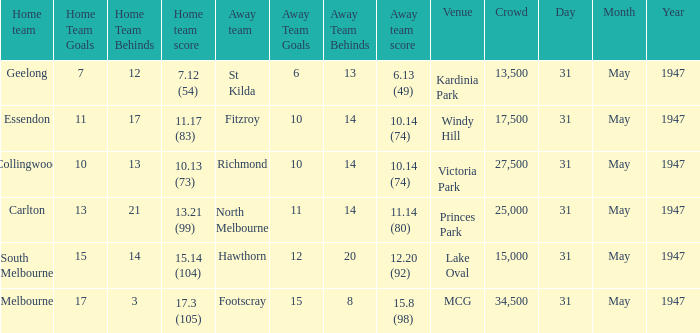Parse the full table. {'header': ['Home team', 'Home Team Goals', 'Home Team Behinds', 'Home team score', 'Away team', 'Away Team Goals', 'Away Team Behinds', 'Away team score', 'Venue', 'Crowd', 'Day', 'Month', 'Year'], 'rows': [['Geelong', '7', '12', '7.12 (54)', 'St Kilda', '6', '13', '6.13 (49)', 'Kardinia Park', '13,500', '31', 'May', '1947'], ['Essendon', '11', '17', '11.17 (83)', 'Fitzroy', '10', '14', '10.14 (74)', 'Windy Hill', '17,500', '31', 'May', '1947'], ['Collingwood', '10', '13', '10.13 (73)', 'Richmond', '10', '14', '10.14 (74)', 'Victoria Park', '27,500', '31', 'May', '1947'], ['Carlton', '13', '21', '13.21 (99)', 'North Melbourne', '11', '14', '11.14 (80)', 'Princes Park', '25,000', '31', 'May', '1947'], ['South Melbourne', '15', '14', '15.14 (104)', 'Hawthorn', '12', '20', '12.20 (92)', 'Lake Oval', '15,000', '31', 'May', '1947'], ['Melbourne', '17', '3', '17.3 (105)', 'Footscray', '15', '8', '15.8 (98)', 'MCG', '34,500', '31', 'May', '1947']]} What is the home team's score at mcg? 17.3 (105). 